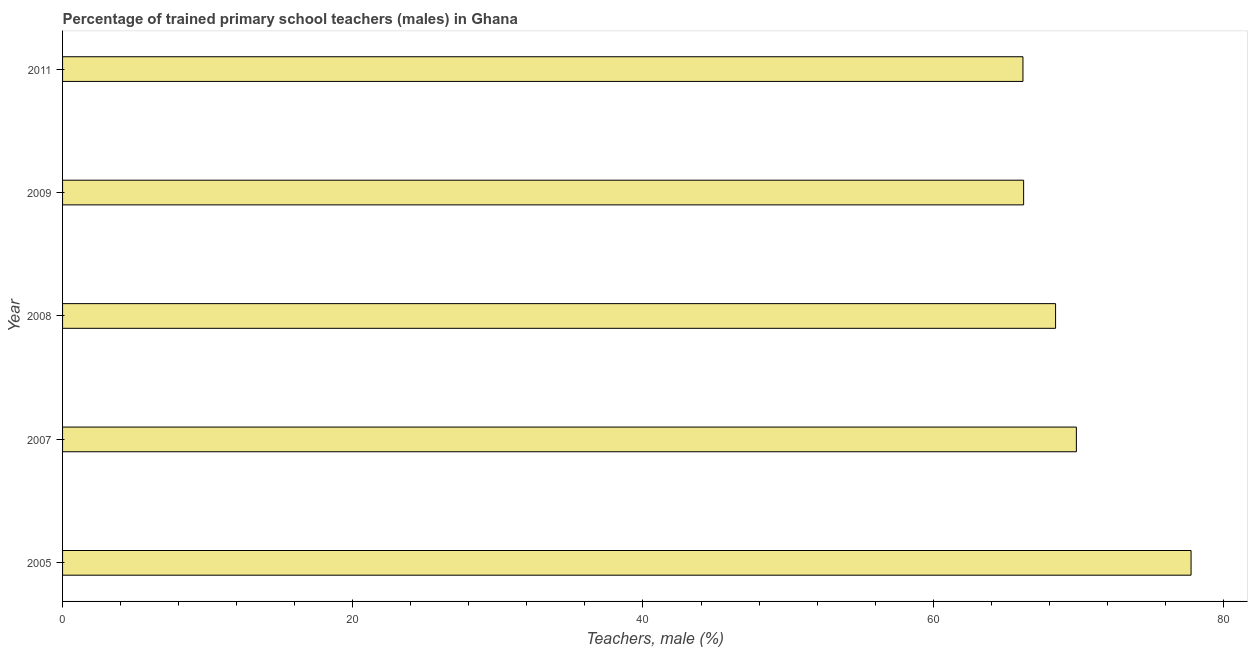Does the graph contain grids?
Your answer should be compact. No. What is the title of the graph?
Provide a succinct answer. Percentage of trained primary school teachers (males) in Ghana. What is the label or title of the X-axis?
Make the answer very short. Teachers, male (%). What is the label or title of the Y-axis?
Your answer should be very brief. Year. What is the percentage of trained male teachers in 2005?
Ensure brevity in your answer.  77.77. Across all years, what is the maximum percentage of trained male teachers?
Provide a short and direct response. 77.77. Across all years, what is the minimum percentage of trained male teachers?
Your answer should be compact. 66.19. What is the sum of the percentage of trained male teachers?
Your answer should be very brief. 348.5. What is the difference between the percentage of trained male teachers in 2005 and 2008?
Your response must be concise. 9.34. What is the average percentage of trained male teachers per year?
Give a very brief answer. 69.7. What is the median percentage of trained male teachers?
Ensure brevity in your answer.  68.44. What is the ratio of the percentage of trained male teachers in 2009 to that in 2011?
Offer a terse response. 1. What is the difference between the highest and the second highest percentage of trained male teachers?
Offer a terse response. 7.9. What is the difference between the highest and the lowest percentage of trained male teachers?
Your answer should be compact. 11.59. How many bars are there?
Provide a short and direct response. 5. Are all the bars in the graph horizontal?
Offer a terse response. Yes. Are the values on the major ticks of X-axis written in scientific E-notation?
Give a very brief answer. No. What is the Teachers, male (%) of 2005?
Keep it short and to the point. 77.77. What is the Teachers, male (%) of 2007?
Ensure brevity in your answer.  69.87. What is the Teachers, male (%) in 2008?
Give a very brief answer. 68.44. What is the Teachers, male (%) of 2009?
Ensure brevity in your answer.  66.23. What is the Teachers, male (%) of 2011?
Provide a succinct answer. 66.19. What is the difference between the Teachers, male (%) in 2005 and 2007?
Ensure brevity in your answer.  7.9. What is the difference between the Teachers, male (%) in 2005 and 2008?
Offer a terse response. 9.34. What is the difference between the Teachers, male (%) in 2005 and 2009?
Offer a terse response. 11.54. What is the difference between the Teachers, male (%) in 2005 and 2011?
Keep it short and to the point. 11.59. What is the difference between the Teachers, male (%) in 2007 and 2008?
Your answer should be compact. 1.43. What is the difference between the Teachers, male (%) in 2007 and 2009?
Provide a short and direct response. 3.64. What is the difference between the Teachers, male (%) in 2007 and 2011?
Offer a very short reply. 3.68. What is the difference between the Teachers, male (%) in 2008 and 2009?
Offer a very short reply. 2.2. What is the difference between the Teachers, male (%) in 2008 and 2011?
Give a very brief answer. 2.25. What is the difference between the Teachers, male (%) in 2009 and 2011?
Ensure brevity in your answer.  0.05. What is the ratio of the Teachers, male (%) in 2005 to that in 2007?
Your answer should be very brief. 1.11. What is the ratio of the Teachers, male (%) in 2005 to that in 2008?
Keep it short and to the point. 1.14. What is the ratio of the Teachers, male (%) in 2005 to that in 2009?
Your answer should be compact. 1.17. What is the ratio of the Teachers, male (%) in 2005 to that in 2011?
Your answer should be compact. 1.18. What is the ratio of the Teachers, male (%) in 2007 to that in 2008?
Give a very brief answer. 1.02. What is the ratio of the Teachers, male (%) in 2007 to that in 2009?
Your response must be concise. 1.05. What is the ratio of the Teachers, male (%) in 2007 to that in 2011?
Ensure brevity in your answer.  1.06. What is the ratio of the Teachers, male (%) in 2008 to that in 2009?
Make the answer very short. 1.03. What is the ratio of the Teachers, male (%) in 2008 to that in 2011?
Provide a succinct answer. 1.03. What is the ratio of the Teachers, male (%) in 2009 to that in 2011?
Keep it short and to the point. 1. 